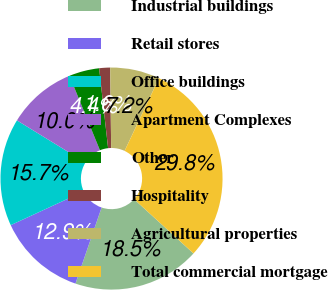Convert chart to OTSL. <chart><loc_0><loc_0><loc_500><loc_500><pie_chart><fcel>Industrial buildings<fcel>Retail stores<fcel>Office buildings<fcel>Apartment Complexes<fcel>Other<fcel>Hospitality<fcel>Agricultural properties<fcel>Total commercial mortgage<nl><fcel>18.48%<fcel>12.85%<fcel>15.67%<fcel>10.04%<fcel>4.4%<fcel>1.59%<fcel>7.22%<fcel>29.75%<nl></chart> 